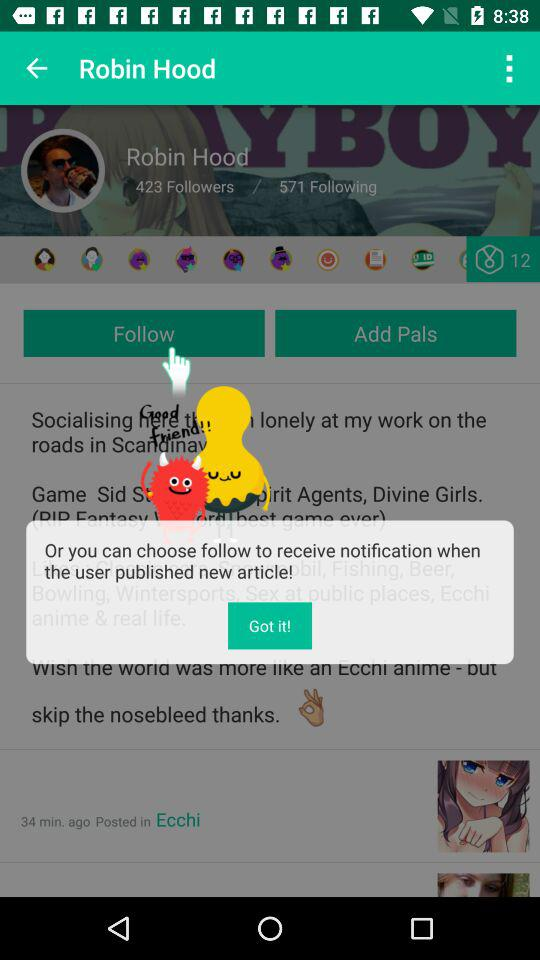How many "Following" does Robin Hood have? There are 571 "Following". 